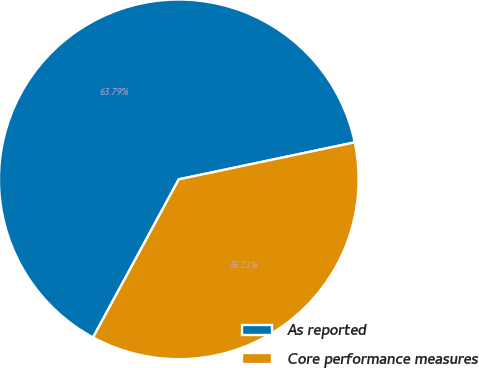Convert chart to OTSL. <chart><loc_0><loc_0><loc_500><loc_500><pie_chart><fcel>As reported<fcel>Core performance measures<nl><fcel>63.79%<fcel>36.21%<nl></chart> 